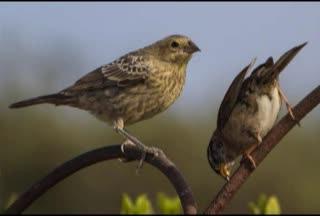How many birds are in the photograph?
Give a very brief answer. 2. 